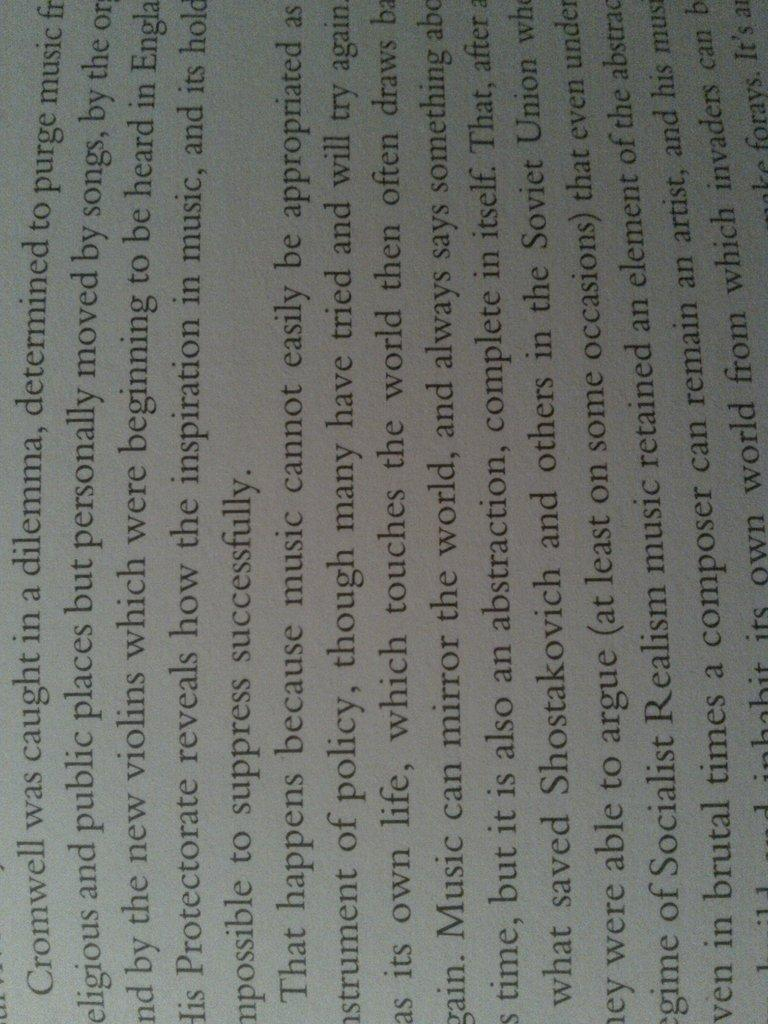Provide a one-sentence caption for the provided image. a sideways piece of text which begins with the word Cromwell. 